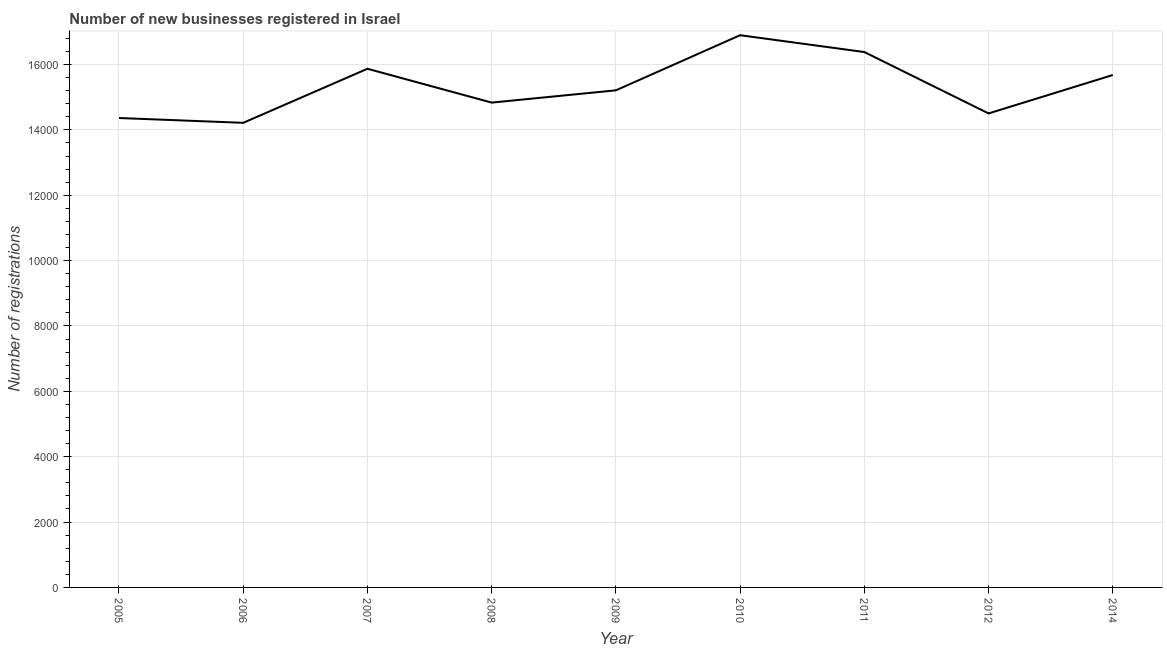What is the number of new business registrations in 2009?
Make the answer very short. 1.52e+04. Across all years, what is the maximum number of new business registrations?
Offer a very short reply. 1.69e+04. Across all years, what is the minimum number of new business registrations?
Your response must be concise. 1.42e+04. In which year was the number of new business registrations maximum?
Offer a terse response. 2010. In which year was the number of new business registrations minimum?
Provide a short and direct response. 2006. What is the sum of the number of new business registrations?
Your answer should be compact. 1.38e+05. What is the difference between the number of new business registrations in 2007 and 2011?
Ensure brevity in your answer.  -512. What is the average number of new business registrations per year?
Your answer should be compact. 1.53e+04. What is the median number of new business registrations?
Offer a terse response. 1.52e+04. What is the ratio of the number of new business registrations in 2008 to that in 2012?
Your answer should be compact. 1.02. Is the difference between the number of new business registrations in 2009 and 2012 greater than the difference between any two years?
Provide a succinct answer. No. What is the difference between the highest and the second highest number of new business registrations?
Provide a short and direct response. 515. Is the sum of the number of new business registrations in 2005 and 2008 greater than the maximum number of new business registrations across all years?
Your answer should be very brief. Yes. What is the difference between the highest and the lowest number of new business registrations?
Offer a terse response. 2681. In how many years, is the number of new business registrations greater than the average number of new business registrations taken over all years?
Your answer should be very brief. 4. Does the number of new business registrations monotonically increase over the years?
Give a very brief answer. No. How many lines are there?
Your answer should be very brief. 1. How many years are there in the graph?
Provide a short and direct response. 9. What is the title of the graph?
Offer a terse response. Number of new businesses registered in Israel. What is the label or title of the X-axis?
Offer a very short reply. Year. What is the label or title of the Y-axis?
Keep it short and to the point. Number of registrations. What is the Number of registrations in 2005?
Offer a very short reply. 1.44e+04. What is the Number of registrations of 2006?
Provide a short and direct response. 1.42e+04. What is the Number of registrations of 2007?
Provide a succinct answer. 1.59e+04. What is the Number of registrations in 2008?
Offer a terse response. 1.48e+04. What is the Number of registrations of 2009?
Ensure brevity in your answer.  1.52e+04. What is the Number of registrations in 2010?
Keep it short and to the point. 1.69e+04. What is the Number of registrations of 2011?
Make the answer very short. 1.64e+04. What is the Number of registrations in 2012?
Your answer should be compact. 1.45e+04. What is the Number of registrations of 2014?
Give a very brief answer. 1.57e+04. What is the difference between the Number of registrations in 2005 and 2006?
Provide a succinct answer. 147. What is the difference between the Number of registrations in 2005 and 2007?
Offer a very short reply. -1507. What is the difference between the Number of registrations in 2005 and 2008?
Your answer should be compact. -472. What is the difference between the Number of registrations in 2005 and 2009?
Provide a short and direct response. -847. What is the difference between the Number of registrations in 2005 and 2010?
Provide a succinct answer. -2534. What is the difference between the Number of registrations in 2005 and 2011?
Make the answer very short. -2019. What is the difference between the Number of registrations in 2005 and 2012?
Offer a very short reply. -140. What is the difference between the Number of registrations in 2005 and 2014?
Make the answer very short. -1316. What is the difference between the Number of registrations in 2006 and 2007?
Your response must be concise. -1654. What is the difference between the Number of registrations in 2006 and 2008?
Make the answer very short. -619. What is the difference between the Number of registrations in 2006 and 2009?
Give a very brief answer. -994. What is the difference between the Number of registrations in 2006 and 2010?
Provide a succinct answer. -2681. What is the difference between the Number of registrations in 2006 and 2011?
Give a very brief answer. -2166. What is the difference between the Number of registrations in 2006 and 2012?
Your answer should be compact. -287. What is the difference between the Number of registrations in 2006 and 2014?
Offer a terse response. -1463. What is the difference between the Number of registrations in 2007 and 2008?
Keep it short and to the point. 1035. What is the difference between the Number of registrations in 2007 and 2009?
Provide a succinct answer. 660. What is the difference between the Number of registrations in 2007 and 2010?
Your response must be concise. -1027. What is the difference between the Number of registrations in 2007 and 2011?
Your answer should be compact. -512. What is the difference between the Number of registrations in 2007 and 2012?
Provide a short and direct response. 1367. What is the difference between the Number of registrations in 2007 and 2014?
Your response must be concise. 191. What is the difference between the Number of registrations in 2008 and 2009?
Provide a short and direct response. -375. What is the difference between the Number of registrations in 2008 and 2010?
Ensure brevity in your answer.  -2062. What is the difference between the Number of registrations in 2008 and 2011?
Provide a succinct answer. -1547. What is the difference between the Number of registrations in 2008 and 2012?
Your answer should be compact. 332. What is the difference between the Number of registrations in 2008 and 2014?
Give a very brief answer. -844. What is the difference between the Number of registrations in 2009 and 2010?
Make the answer very short. -1687. What is the difference between the Number of registrations in 2009 and 2011?
Offer a very short reply. -1172. What is the difference between the Number of registrations in 2009 and 2012?
Provide a short and direct response. 707. What is the difference between the Number of registrations in 2009 and 2014?
Give a very brief answer. -469. What is the difference between the Number of registrations in 2010 and 2011?
Offer a very short reply. 515. What is the difference between the Number of registrations in 2010 and 2012?
Your response must be concise. 2394. What is the difference between the Number of registrations in 2010 and 2014?
Provide a short and direct response. 1218. What is the difference between the Number of registrations in 2011 and 2012?
Give a very brief answer. 1879. What is the difference between the Number of registrations in 2011 and 2014?
Your answer should be very brief. 703. What is the difference between the Number of registrations in 2012 and 2014?
Offer a terse response. -1176. What is the ratio of the Number of registrations in 2005 to that in 2006?
Your answer should be very brief. 1.01. What is the ratio of the Number of registrations in 2005 to that in 2007?
Keep it short and to the point. 0.91. What is the ratio of the Number of registrations in 2005 to that in 2009?
Your answer should be compact. 0.94. What is the ratio of the Number of registrations in 2005 to that in 2010?
Provide a succinct answer. 0.85. What is the ratio of the Number of registrations in 2005 to that in 2011?
Give a very brief answer. 0.88. What is the ratio of the Number of registrations in 2005 to that in 2012?
Your answer should be compact. 0.99. What is the ratio of the Number of registrations in 2005 to that in 2014?
Your answer should be compact. 0.92. What is the ratio of the Number of registrations in 2006 to that in 2007?
Make the answer very short. 0.9. What is the ratio of the Number of registrations in 2006 to that in 2008?
Provide a succinct answer. 0.96. What is the ratio of the Number of registrations in 2006 to that in 2009?
Provide a short and direct response. 0.94. What is the ratio of the Number of registrations in 2006 to that in 2010?
Your answer should be compact. 0.84. What is the ratio of the Number of registrations in 2006 to that in 2011?
Keep it short and to the point. 0.87. What is the ratio of the Number of registrations in 2006 to that in 2014?
Offer a terse response. 0.91. What is the ratio of the Number of registrations in 2007 to that in 2008?
Your answer should be very brief. 1.07. What is the ratio of the Number of registrations in 2007 to that in 2009?
Your answer should be compact. 1.04. What is the ratio of the Number of registrations in 2007 to that in 2010?
Your answer should be compact. 0.94. What is the ratio of the Number of registrations in 2007 to that in 2012?
Provide a short and direct response. 1.09. What is the ratio of the Number of registrations in 2007 to that in 2014?
Keep it short and to the point. 1.01. What is the ratio of the Number of registrations in 2008 to that in 2009?
Your answer should be very brief. 0.97. What is the ratio of the Number of registrations in 2008 to that in 2010?
Offer a very short reply. 0.88. What is the ratio of the Number of registrations in 2008 to that in 2011?
Your answer should be very brief. 0.91. What is the ratio of the Number of registrations in 2008 to that in 2012?
Keep it short and to the point. 1.02. What is the ratio of the Number of registrations in 2008 to that in 2014?
Provide a succinct answer. 0.95. What is the ratio of the Number of registrations in 2009 to that in 2010?
Keep it short and to the point. 0.9. What is the ratio of the Number of registrations in 2009 to that in 2011?
Your answer should be very brief. 0.93. What is the ratio of the Number of registrations in 2009 to that in 2012?
Keep it short and to the point. 1.05. What is the ratio of the Number of registrations in 2009 to that in 2014?
Keep it short and to the point. 0.97. What is the ratio of the Number of registrations in 2010 to that in 2011?
Provide a short and direct response. 1.03. What is the ratio of the Number of registrations in 2010 to that in 2012?
Your answer should be very brief. 1.17. What is the ratio of the Number of registrations in 2010 to that in 2014?
Offer a terse response. 1.08. What is the ratio of the Number of registrations in 2011 to that in 2012?
Provide a succinct answer. 1.13. What is the ratio of the Number of registrations in 2011 to that in 2014?
Provide a succinct answer. 1.04. What is the ratio of the Number of registrations in 2012 to that in 2014?
Offer a very short reply. 0.93. 